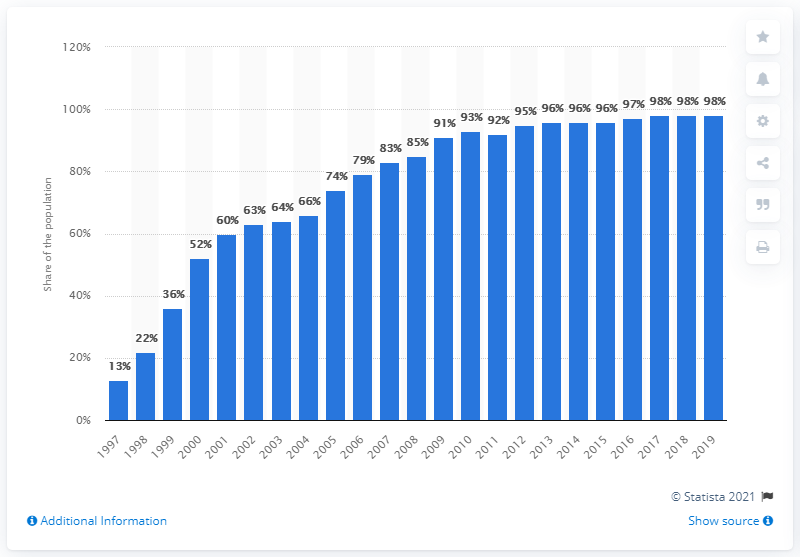Draw attention to some important aspects in this diagram. In 1997, approximately 13% of the population in Norway had access to the internet. In 2019, approximately 98% of the population in Norway had access to the internet. 